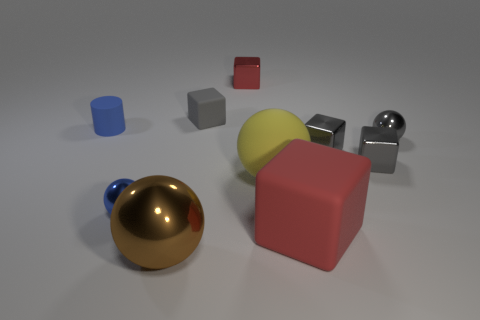If I were to touch the red cube, what might it feel like? The red cube appears to have a matte surface, which might give it a slightly rough texture. Its sharp edges and solid appearance suggest it would feel firm and sturdy. 